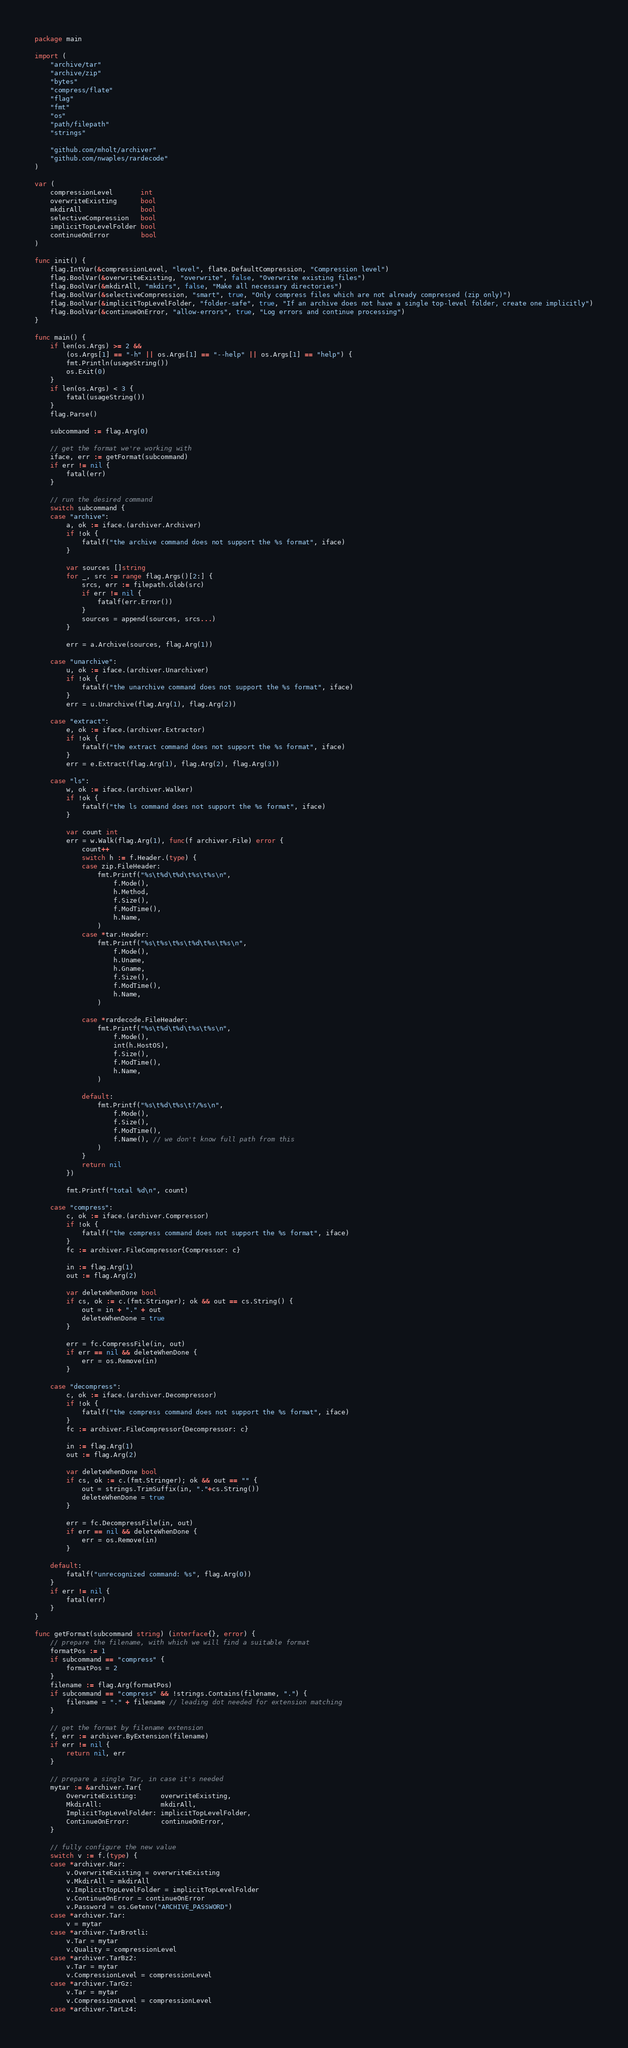Convert code to text. <code><loc_0><loc_0><loc_500><loc_500><_Go_>package main

import (
	"archive/tar"
	"archive/zip"
	"bytes"
	"compress/flate"
	"flag"
	"fmt"
	"os"
	"path/filepath"
	"strings"

	"github.com/mholt/archiver"
	"github.com/nwaples/rardecode"
)

var (
	compressionLevel       int
	overwriteExisting      bool
	mkdirAll               bool
	selectiveCompression   bool
	implicitTopLevelFolder bool
	continueOnError        bool
)

func init() {
	flag.IntVar(&compressionLevel, "level", flate.DefaultCompression, "Compression level")
	flag.BoolVar(&overwriteExisting, "overwrite", false, "Overwrite existing files")
	flag.BoolVar(&mkdirAll, "mkdirs", false, "Make all necessary directories")
	flag.BoolVar(&selectiveCompression, "smart", true, "Only compress files which are not already compressed (zip only)")
	flag.BoolVar(&implicitTopLevelFolder, "folder-safe", true, "If an archive does not have a single top-level folder, create one implicitly")
	flag.BoolVar(&continueOnError, "allow-errors", true, "Log errors and continue processing")
}

func main() {
	if len(os.Args) >= 2 &&
		(os.Args[1] == "-h" || os.Args[1] == "--help" || os.Args[1] == "help") {
		fmt.Println(usageString())
		os.Exit(0)
	}
	if len(os.Args) < 3 {
		fatal(usageString())
	}
	flag.Parse()

	subcommand := flag.Arg(0)

	// get the format we're working with
	iface, err := getFormat(subcommand)
	if err != nil {
		fatal(err)
	}

	// run the desired command
	switch subcommand {
	case "archive":
		a, ok := iface.(archiver.Archiver)
		if !ok {
			fatalf("the archive command does not support the %s format", iface)
		}

		var sources []string
		for _, src := range flag.Args()[2:] {
			srcs, err := filepath.Glob(src)
			if err != nil {
				fatalf(err.Error())
			}
			sources = append(sources, srcs...)
		}

		err = a.Archive(sources, flag.Arg(1))

	case "unarchive":
		u, ok := iface.(archiver.Unarchiver)
		if !ok {
			fatalf("the unarchive command does not support the %s format", iface)
		}
		err = u.Unarchive(flag.Arg(1), flag.Arg(2))

	case "extract":
		e, ok := iface.(archiver.Extractor)
		if !ok {
			fatalf("the extract command does not support the %s format", iface)
		}
		err = e.Extract(flag.Arg(1), flag.Arg(2), flag.Arg(3))

	case "ls":
		w, ok := iface.(archiver.Walker)
		if !ok {
			fatalf("the ls command does not support the %s format", iface)
		}

		var count int
		err = w.Walk(flag.Arg(1), func(f archiver.File) error {
			count++
			switch h := f.Header.(type) {
			case zip.FileHeader:
				fmt.Printf("%s\t%d\t%d\t%s\t%s\n",
					f.Mode(),
					h.Method,
					f.Size(),
					f.ModTime(),
					h.Name,
				)
			case *tar.Header:
				fmt.Printf("%s\t%s\t%s\t%d\t%s\t%s\n",
					f.Mode(),
					h.Uname,
					h.Gname,
					f.Size(),
					f.ModTime(),
					h.Name,
				)

			case *rardecode.FileHeader:
				fmt.Printf("%s\t%d\t%d\t%s\t%s\n",
					f.Mode(),
					int(h.HostOS),
					f.Size(),
					f.ModTime(),
					h.Name,
				)

			default:
				fmt.Printf("%s\t%d\t%s\t?/%s\n",
					f.Mode(),
					f.Size(),
					f.ModTime(),
					f.Name(), // we don't know full path from this
				)
			}
			return nil
		})

		fmt.Printf("total %d\n", count)

	case "compress":
		c, ok := iface.(archiver.Compressor)
		if !ok {
			fatalf("the compress command does not support the %s format", iface)
		}
		fc := archiver.FileCompressor{Compressor: c}

		in := flag.Arg(1)
		out := flag.Arg(2)

		var deleteWhenDone bool
		if cs, ok := c.(fmt.Stringer); ok && out == cs.String() {
			out = in + "." + out
			deleteWhenDone = true
		}

		err = fc.CompressFile(in, out)
		if err == nil && deleteWhenDone {
			err = os.Remove(in)
		}

	case "decompress":
		c, ok := iface.(archiver.Decompressor)
		if !ok {
			fatalf("the compress command does not support the %s format", iface)
		}
		fc := archiver.FileCompressor{Decompressor: c}

		in := flag.Arg(1)
		out := flag.Arg(2)

		var deleteWhenDone bool
		if cs, ok := c.(fmt.Stringer); ok && out == "" {
			out = strings.TrimSuffix(in, "."+cs.String())
			deleteWhenDone = true
		}

		err = fc.DecompressFile(in, out)
		if err == nil && deleteWhenDone {
			err = os.Remove(in)
		}

	default:
		fatalf("unrecognized command: %s", flag.Arg(0))
	}
	if err != nil {
		fatal(err)
	}
}

func getFormat(subcommand string) (interface{}, error) {
	// prepare the filename, with which we will find a suitable format
	formatPos := 1
	if subcommand == "compress" {
		formatPos = 2
	}
	filename := flag.Arg(formatPos)
	if subcommand == "compress" && !strings.Contains(filename, ".") {
		filename = "." + filename // leading dot needed for extension matching
	}

	// get the format by filename extension
	f, err := archiver.ByExtension(filename)
	if err != nil {
		return nil, err
	}

	// prepare a single Tar, in case it's needed
	mytar := &archiver.Tar{
		OverwriteExisting:      overwriteExisting,
		MkdirAll:               mkdirAll,
		ImplicitTopLevelFolder: implicitTopLevelFolder,
		ContinueOnError:        continueOnError,
	}

	// fully configure the new value
	switch v := f.(type) {
	case *archiver.Rar:
		v.OverwriteExisting = overwriteExisting
		v.MkdirAll = mkdirAll
		v.ImplicitTopLevelFolder = implicitTopLevelFolder
		v.ContinueOnError = continueOnError
		v.Password = os.Getenv("ARCHIVE_PASSWORD")
	case *archiver.Tar:
		v = mytar
	case *archiver.TarBrotli:
		v.Tar = mytar
		v.Quality = compressionLevel
	case *archiver.TarBz2:
		v.Tar = mytar
		v.CompressionLevel = compressionLevel
	case *archiver.TarGz:
		v.Tar = mytar
		v.CompressionLevel = compressionLevel
	case *archiver.TarLz4:</code> 